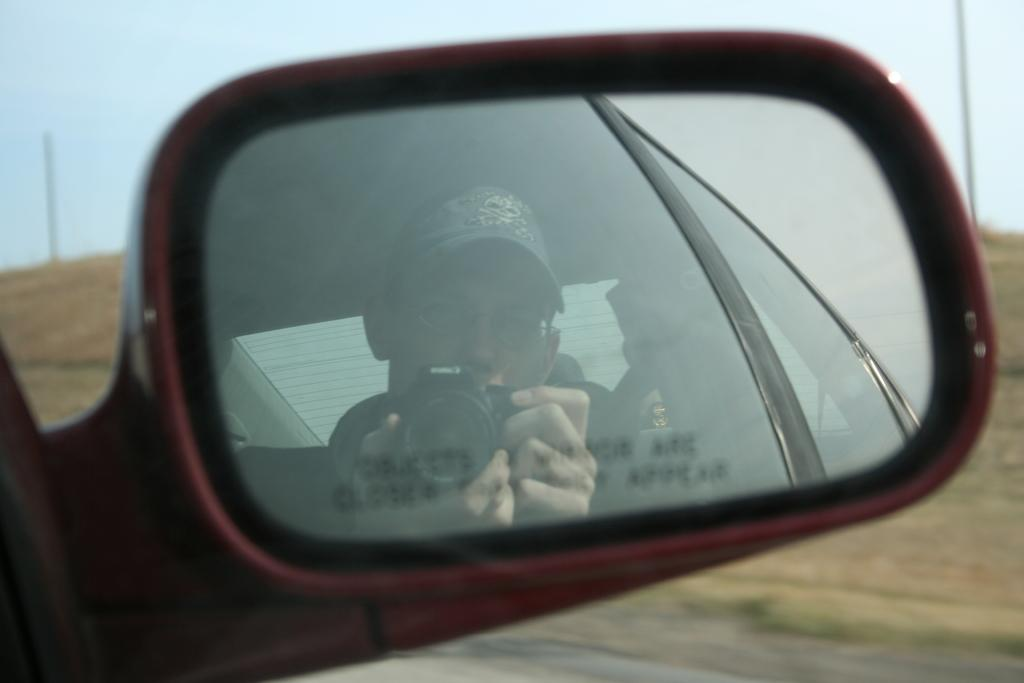What is visible in the image due to a reflection? There is a reflection of a person in the image. What is the person holding in the image? The person is holding a camera. Where is the reflection located in the image? The reflection is on the side mirror of a car. What type of shape does the person's reflection make in the image? A: The person's reflection does not form a specific shape in the image; it is a reflection of the person's appearance. 